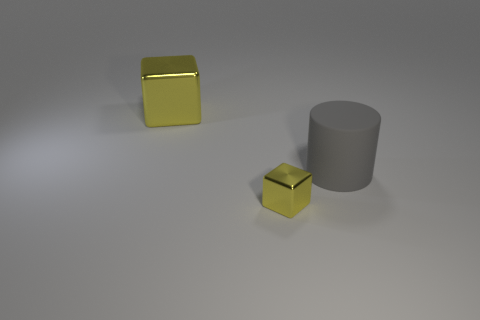Add 1 tiny red metallic blocks. How many objects exist? 4 Subtract all cylinders. How many objects are left? 2 Add 2 big green cubes. How many big green cubes exist? 2 Subtract 0 cyan cylinders. How many objects are left? 3 Subtract all small shiny things. Subtract all gray things. How many objects are left? 1 Add 3 big gray things. How many big gray things are left? 4 